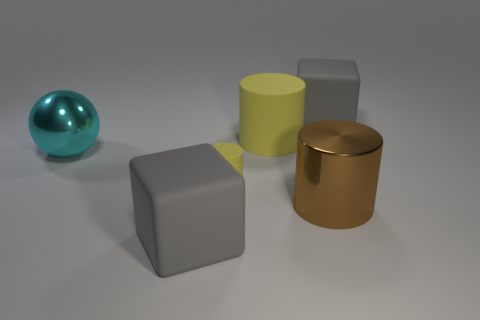There is a rubber object in front of the brown metal thing; is its shape the same as the big gray rubber thing that is behind the big cyan ball?
Provide a short and direct response. Yes. Are there the same number of large gray rubber blocks that are in front of the brown cylinder and big rubber blocks?
Make the answer very short. No. There is a brown object that is the same shape as the tiny yellow thing; what material is it?
Give a very brief answer. Metal. What shape is the metallic thing that is right of the cyan object that is in front of the big rubber cylinder?
Provide a short and direct response. Cylinder. Is the material of the yellow cylinder that is in front of the metallic sphere the same as the big cyan object?
Offer a very short reply. No. Is the number of tiny objects in front of the brown cylinder the same as the number of brown cylinders that are on the left side of the large yellow cylinder?
Offer a very short reply. Yes. There is a big gray matte block left of the tiny matte cylinder; what number of cyan shiny spheres are to the left of it?
Give a very brief answer. 1. There is a rubber cube on the left side of the large brown cylinder; is its color the same as the large matte cube that is behind the cyan metal ball?
Provide a short and direct response. Yes. What is the material of the yellow cylinder that is the same size as the metal sphere?
Your answer should be compact. Rubber. There is a gray object right of the big gray thing left of the matte block behind the big metal cylinder; what shape is it?
Your answer should be compact. Cube. 